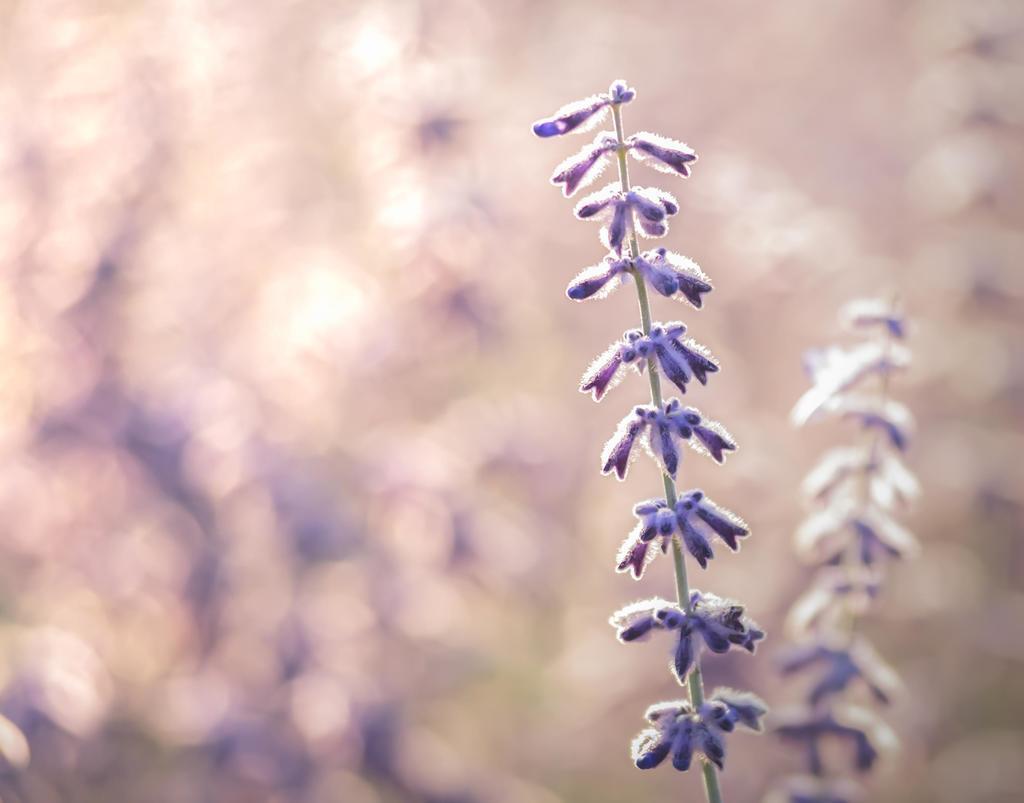Describe this image in one or two sentences. Here I can see a plant along with the flowers which are in violet color. The background is blurred. 